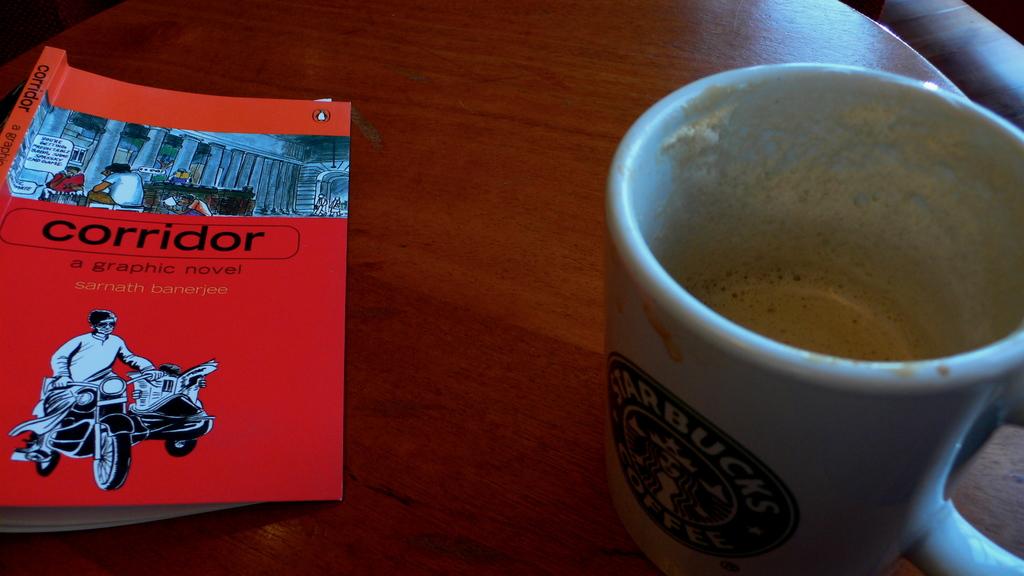What english word is written on the red book?
Your response must be concise. Corridor. What kind of novel is this?
Offer a very short reply. Graphic. 